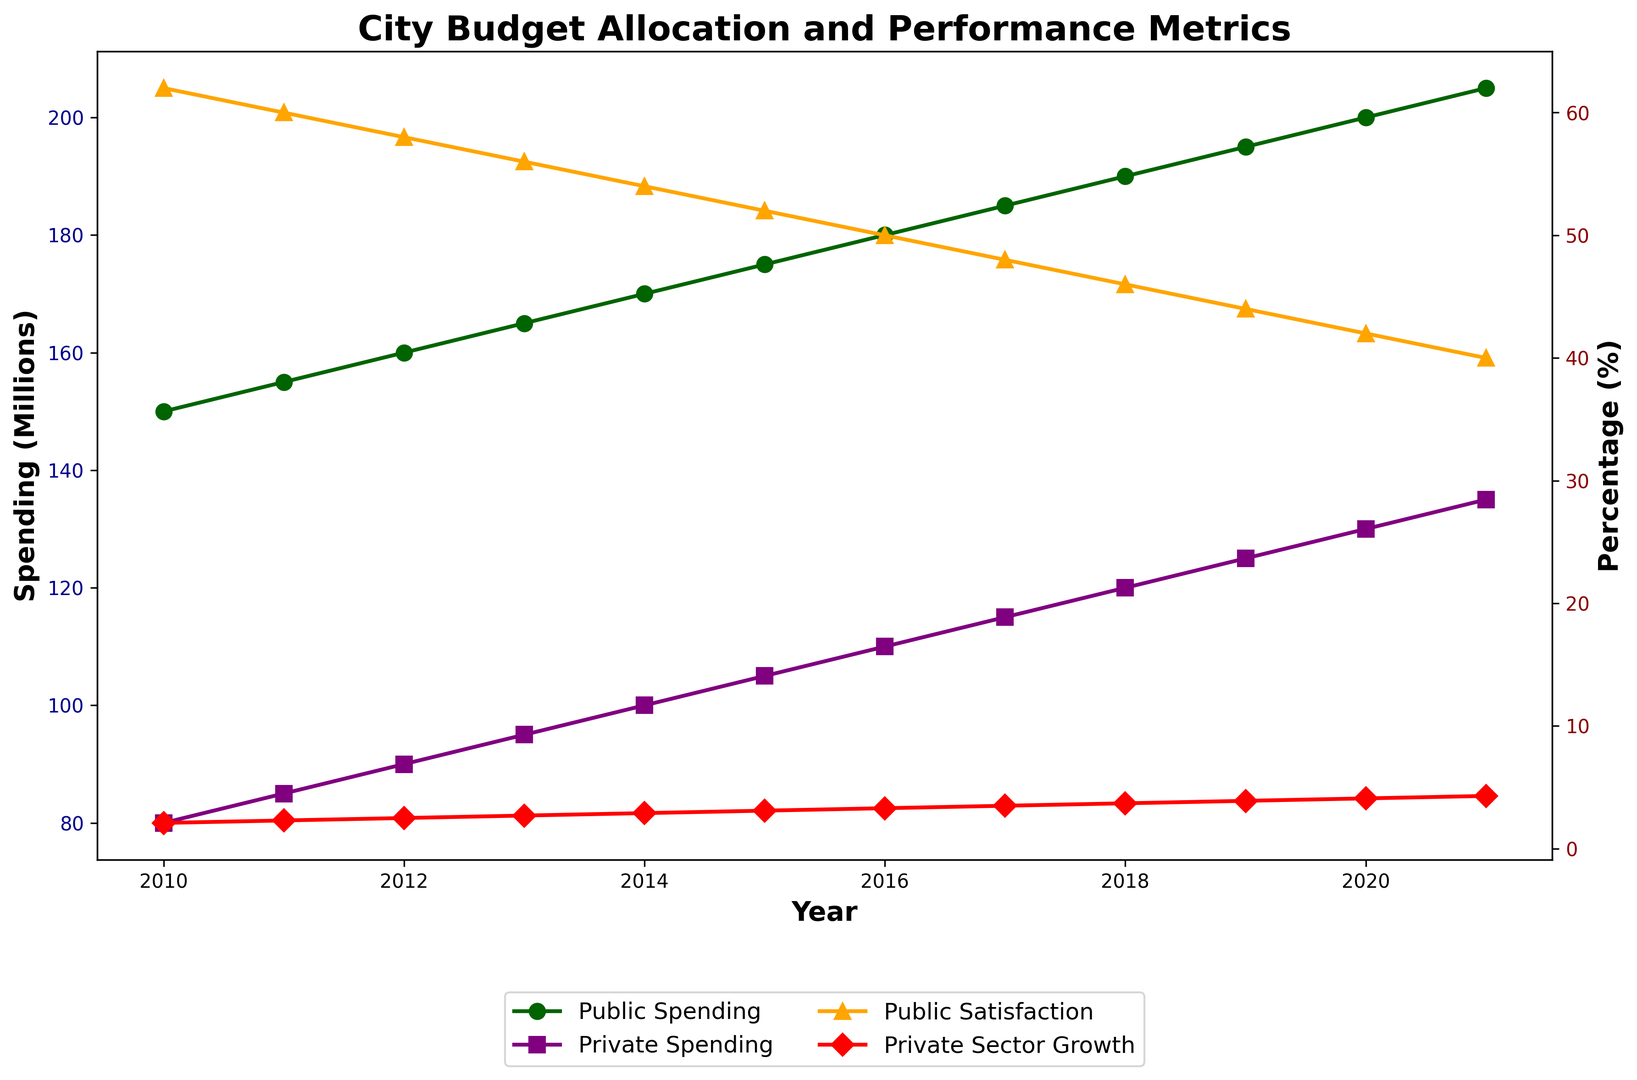What is the trend in public spending from 2010 to 2021? The plot shows an upward trend in public spending over the years from 150 million in 2010 to 205 million in 2021.
Answer: Upward trend Which year had the highest private sector growth? The plot shows the line for Private Sector Growth (%) peaking in 2021 at 4.3%.
Answer: 2021 How does the increase in public spending compare to the increase in private spending from 2010 to 2020? Public spending increased from 150 million in 2010 to 200 million in 2020 (an increase of 50 million), while private spending increased from 80 million to 130 million (an increase of 50 million) over the same period.
Answer: Both increased by 50 million What is the relationship between public satisfaction and public spending? As public spending increased from 150 million to 205 million, public satisfaction decreased from 62% to 40%, indicating an inverse relationship.
Answer: Inverse relationship Which year showed the greatest gap between public satisfaction and private sector growth? The greatest gap appears in 2021 with public satisfaction at 40% and private sector growth at 4.3%, yielding a gap of 35.7%.
Answer: 2021 What colors represent public spending and public satisfaction on the plot? Public spending is represented in dark green, and public satisfaction is represented in orange.
Answer: Dark green and orange What visual elements differ between public spending and private spending lines? Public spending is marked with 'o' (circles) and is dark green, while private spending is marked with 's' (squares) and is purple.
Answer: Marker shapes and colors By how many percentage points did public satisfaction decrease from 2010 to 2015? Public satisfaction decreased from 62% in 2010 to 52% in 2015, a decrease of 10 percentage points.
Answer: 10 percentage points 